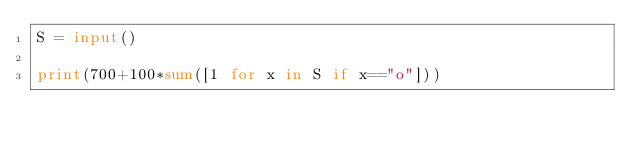Convert code to text. <code><loc_0><loc_0><loc_500><loc_500><_Python_>S = input()

print(700+100*sum([1 for x in S if x=="o"]))</code> 